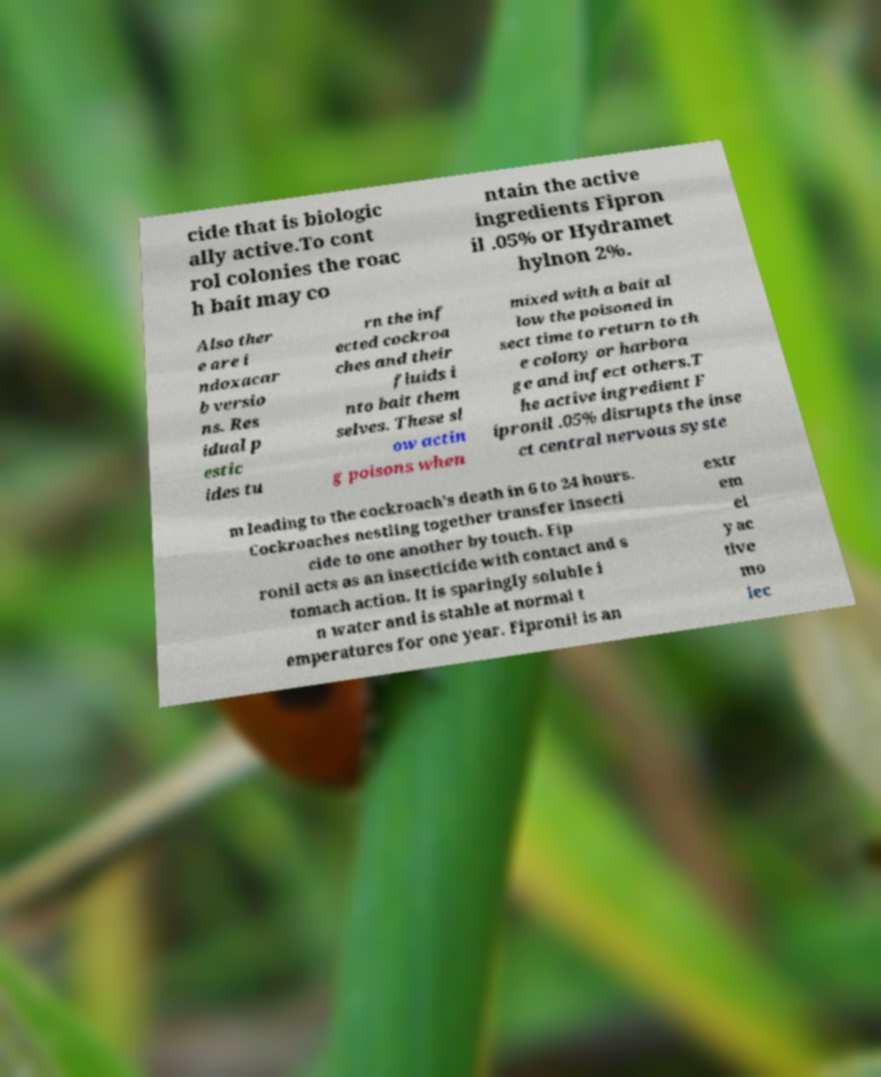I need the written content from this picture converted into text. Can you do that? cide that is biologic ally active.To cont rol colonies the roac h bait may co ntain the active ingredients Fipron il .05% or Hydramet hylnon 2%. Also ther e are i ndoxacar b versio ns. Res idual p estic ides tu rn the inf ected cockroa ches and their fluids i nto bait them selves. These sl ow actin g poisons when mixed with a bait al low the poisoned in sect time to return to th e colony or harbora ge and infect others.T he active ingredient F ipronil .05% disrupts the inse ct central nervous syste m leading to the cockroach’s death in 6 to 24 hours. Cockroaches nestling together transfer insecti cide to one another by touch. Fip ronil acts as an insecticide with contact and s tomach action. It is sparingly soluble i n water and is stable at normal t emperatures for one year. Fipronil is an extr em el y ac tive mo lec 